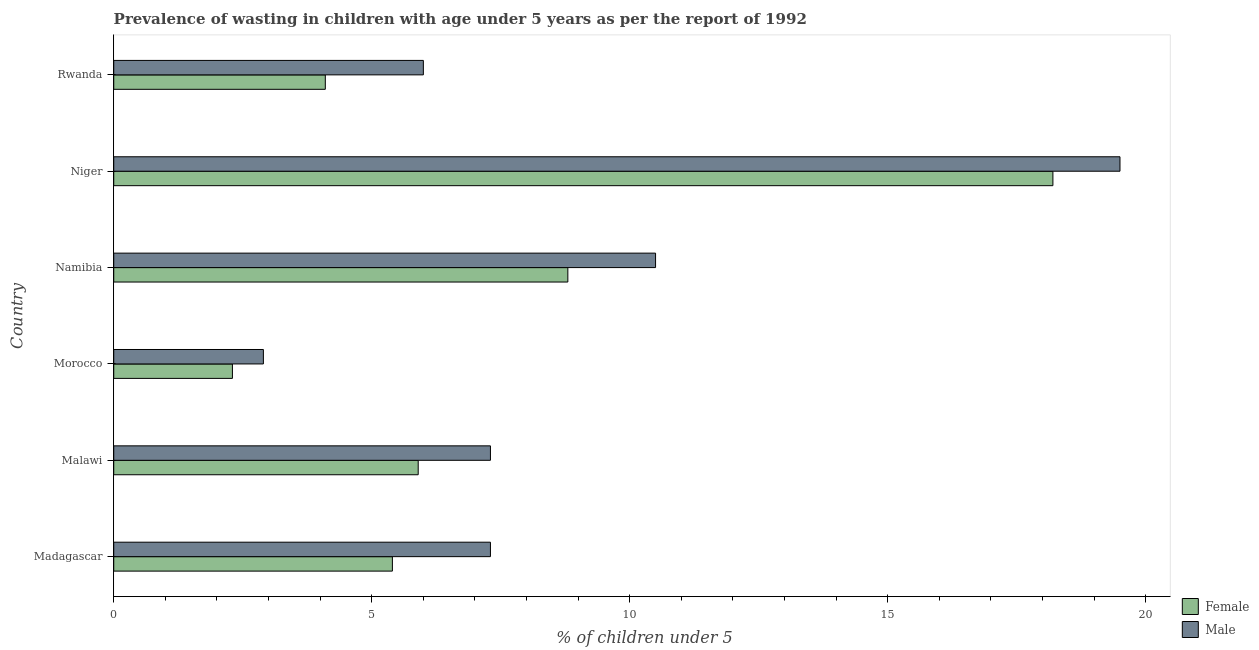How many different coloured bars are there?
Your answer should be compact. 2. How many groups of bars are there?
Offer a terse response. 6. How many bars are there on the 1st tick from the top?
Keep it short and to the point. 2. What is the label of the 4th group of bars from the top?
Make the answer very short. Morocco. In how many cases, is the number of bars for a given country not equal to the number of legend labels?
Provide a short and direct response. 0. What is the percentage of undernourished male children in Niger?
Offer a terse response. 19.5. Across all countries, what is the maximum percentage of undernourished female children?
Keep it short and to the point. 18.2. Across all countries, what is the minimum percentage of undernourished female children?
Provide a succinct answer. 2.3. In which country was the percentage of undernourished male children maximum?
Give a very brief answer. Niger. In which country was the percentage of undernourished male children minimum?
Keep it short and to the point. Morocco. What is the total percentage of undernourished female children in the graph?
Your response must be concise. 44.7. What is the difference between the percentage of undernourished female children in Rwanda and the percentage of undernourished male children in Malawi?
Your answer should be very brief. -3.2. What is the average percentage of undernourished female children per country?
Offer a terse response. 7.45. What is the difference between the percentage of undernourished male children and percentage of undernourished female children in Niger?
Provide a short and direct response. 1.3. What is the ratio of the percentage of undernourished male children in Malawi to that in Morocco?
Ensure brevity in your answer.  2.52. Is the percentage of undernourished male children in Morocco less than that in Namibia?
Ensure brevity in your answer.  Yes. What is the difference between the highest and the lowest percentage of undernourished female children?
Your answer should be very brief. 15.9. In how many countries, is the percentage of undernourished female children greater than the average percentage of undernourished female children taken over all countries?
Your answer should be very brief. 2. Is the sum of the percentage of undernourished female children in Madagascar and Niger greater than the maximum percentage of undernourished male children across all countries?
Offer a very short reply. Yes. How many bars are there?
Keep it short and to the point. 12. Are all the bars in the graph horizontal?
Your answer should be very brief. Yes. How many countries are there in the graph?
Your answer should be very brief. 6. Are the values on the major ticks of X-axis written in scientific E-notation?
Your response must be concise. No. How are the legend labels stacked?
Provide a succinct answer. Vertical. What is the title of the graph?
Ensure brevity in your answer.  Prevalence of wasting in children with age under 5 years as per the report of 1992. Does "Formally registered" appear as one of the legend labels in the graph?
Your answer should be very brief. No. What is the label or title of the X-axis?
Give a very brief answer.  % of children under 5. What is the  % of children under 5 in Female in Madagascar?
Give a very brief answer. 5.4. What is the  % of children under 5 of Male in Madagascar?
Offer a very short reply. 7.3. What is the  % of children under 5 of Female in Malawi?
Offer a terse response. 5.9. What is the  % of children under 5 in Male in Malawi?
Your answer should be very brief. 7.3. What is the  % of children under 5 in Female in Morocco?
Keep it short and to the point. 2.3. What is the  % of children under 5 in Male in Morocco?
Offer a terse response. 2.9. What is the  % of children under 5 in Female in Namibia?
Provide a succinct answer. 8.8. What is the  % of children under 5 of Female in Niger?
Your answer should be compact. 18.2. What is the  % of children under 5 in Male in Niger?
Give a very brief answer. 19.5. What is the  % of children under 5 of Female in Rwanda?
Your response must be concise. 4.1. Across all countries, what is the maximum  % of children under 5 in Female?
Ensure brevity in your answer.  18.2. Across all countries, what is the minimum  % of children under 5 in Female?
Your response must be concise. 2.3. Across all countries, what is the minimum  % of children under 5 in Male?
Provide a short and direct response. 2.9. What is the total  % of children under 5 of Female in the graph?
Keep it short and to the point. 44.7. What is the total  % of children under 5 of Male in the graph?
Provide a succinct answer. 53.5. What is the difference between the  % of children under 5 in Female in Madagascar and that in Malawi?
Your answer should be compact. -0.5. What is the difference between the  % of children under 5 in Male in Madagascar and that in Malawi?
Keep it short and to the point. 0. What is the difference between the  % of children under 5 of Male in Madagascar and that in Namibia?
Provide a succinct answer. -3.2. What is the difference between the  % of children under 5 in Female in Madagascar and that in Niger?
Give a very brief answer. -12.8. What is the difference between the  % of children under 5 of Female in Madagascar and that in Rwanda?
Offer a very short reply. 1.3. What is the difference between the  % of children under 5 of Female in Malawi and that in Morocco?
Your answer should be very brief. 3.6. What is the difference between the  % of children under 5 in Female in Malawi and that in Niger?
Ensure brevity in your answer.  -12.3. What is the difference between the  % of children under 5 of Male in Malawi and that in Niger?
Make the answer very short. -12.2. What is the difference between the  % of children under 5 in Female in Malawi and that in Rwanda?
Your response must be concise. 1.8. What is the difference between the  % of children under 5 of Male in Morocco and that in Namibia?
Your answer should be compact. -7.6. What is the difference between the  % of children under 5 in Female in Morocco and that in Niger?
Offer a terse response. -15.9. What is the difference between the  % of children under 5 of Male in Morocco and that in Niger?
Your answer should be very brief. -16.6. What is the difference between the  % of children under 5 in Female in Morocco and that in Rwanda?
Your answer should be very brief. -1.8. What is the difference between the  % of children under 5 of Female in Namibia and that in Niger?
Ensure brevity in your answer.  -9.4. What is the difference between the  % of children under 5 of Male in Namibia and that in Rwanda?
Your response must be concise. 4.5. What is the difference between the  % of children under 5 of Male in Niger and that in Rwanda?
Offer a terse response. 13.5. What is the difference between the  % of children under 5 in Female in Madagascar and the  % of children under 5 in Male in Malawi?
Your response must be concise. -1.9. What is the difference between the  % of children under 5 of Female in Madagascar and the  % of children under 5 of Male in Namibia?
Provide a short and direct response. -5.1. What is the difference between the  % of children under 5 in Female in Madagascar and the  % of children under 5 in Male in Niger?
Ensure brevity in your answer.  -14.1. What is the difference between the  % of children under 5 of Female in Madagascar and the  % of children under 5 of Male in Rwanda?
Your response must be concise. -0.6. What is the difference between the  % of children under 5 of Female in Malawi and the  % of children under 5 of Male in Morocco?
Provide a succinct answer. 3. What is the difference between the  % of children under 5 of Female in Malawi and the  % of children under 5 of Male in Namibia?
Your response must be concise. -4.6. What is the difference between the  % of children under 5 of Female in Malawi and the  % of children under 5 of Male in Niger?
Keep it short and to the point. -13.6. What is the difference between the  % of children under 5 of Female in Morocco and the  % of children under 5 of Male in Niger?
Provide a short and direct response. -17.2. What is the difference between the  % of children under 5 of Female in Namibia and the  % of children under 5 of Male in Rwanda?
Provide a succinct answer. 2.8. What is the difference between the  % of children under 5 in Female in Niger and the  % of children under 5 in Male in Rwanda?
Make the answer very short. 12.2. What is the average  % of children under 5 in Female per country?
Ensure brevity in your answer.  7.45. What is the average  % of children under 5 of Male per country?
Ensure brevity in your answer.  8.92. What is the difference between the  % of children under 5 in Female and  % of children under 5 in Male in Madagascar?
Keep it short and to the point. -1.9. What is the difference between the  % of children under 5 of Female and  % of children under 5 of Male in Malawi?
Make the answer very short. -1.4. What is the difference between the  % of children under 5 of Female and  % of children under 5 of Male in Morocco?
Offer a very short reply. -0.6. What is the difference between the  % of children under 5 of Female and  % of children under 5 of Male in Niger?
Offer a very short reply. -1.3. What is the ratio of the  % of children under 5 of Female in Madagascar to that in Malawi?
Make the answer very short. 0.92. What is the ratio of the  % of children under 5 in Female in Madagascar to that in Morocco?
Your response must be concise. 2.35. What is the ratio of the  % of children under 5 of Male in Madagascar to that in Morocco?
Offer a very short reply. 2.52. What is the ratio of the  % of children under 5 in Female in Madagascar to that in Namibia?
Offer a very short reply. 0.61. What is the ratio of the  % of children under 5 in Male in Madagascar to that in Namibia?
Your answer should be compact. 0.7. What is the ratio of the  % of children under 5 of Female in Madagascar to that in Niger?
Give a very brief answer. 0.3. What is the ratio of the  % of children under 5 of Male in Madagascar to that in Niger?
Make the answer very short. 0.37. What is the ratio of the  % of children under 5 in Female in Madagascar to that in Rwanda?
Your answer should be very brief. 1.32. What is the ratio of the  % of children under 5 in Male in Madagascar to that in Rwanda?
Offer a very short reply. 1.22. What is the ratio of the  % of children under 5 in Female in Malawi to that in Morocco?
Your answer should be very brief. 2.57. What is the ratio of the  % of children under 5 of Male in Malawi to that in Morocco?
Offer a terse response. 2.52. What is the ratio of the  % of children under 5 in Female in Malawi to that in Namibia?
Your answer should be compact. 0.67. What is the ratio of the  % of children under 5 in Male in Malawi to that in Namibia?
Make the answer very short. 0.7. What is the ratio of the  % of children under 5 of Female in Malawi to that in Niger?
Make the answer very short. 0.32. What is the ratio of the  % of children under 5 in Male in Malawi to that in Niger?
Your answer should be compact. 0.37. What is the ratio of the  % of children under 5 in Female in Malawi to that in Rwanda?
Your answer should be compact. 1.44. What is the ratio of the  % of children under 5 of Male in Malawi to that in Rwanda?
Provide a short and direct response. 1.22. What is the ratio of the  % of children under 5 of Female in Morocco to that in Namibia?
Provide a short and direct response. 0.26. What is the ratio of the  % of children under 5 in Male in Morocco to that in Namibia?
Make the answer very short. 0.28. What is the ratio of the  % of children under 5 in Female in Morocco to that in Niger?
Your answer should be very brief. 0.13. What is the ratio of the  % of children under 5 of Male in Morocco to that in Niger?
Provide a succinct answer. 0.15. What is the ratio of the  % of children under 5 in Female in Morocco to that in Rwanda?
Provide a short and direct response. 0.56. What is the ratio of the  % of children under 5 of Male in Morocco to that in Rwanda?
Provide a short and direct response. 0.48. What is the ratio of the  % of children under 5 in Female in Namibia to that in Niger?
Give a very brief answer. 0.48. What is the ratio of the  % of children under 5 in Male in Namibia to that in Niger?
Provide a succinct answer. 0.54. What is the ratio of the  % of children under 5 in Female in Namibia to that in Rwanda?
Ensure brevity in your answer.  2.15. What is the ratio of the  % of children under 5 in Female in Niger to that in Rwanda?
Offer a very short reply. 4.44. What is the ratio of the  % of children under 5 of Male in Niger to that in Rwanda?
Give a very brief answer. 3.25. What is the difference between the highest and the lowest  % of children under 5 in Female?
Give a very brief answer. 15.9. What is the difference between the highest and the lowest  % of children under 5 of Male?
Offer a very short reply. 16.6. 